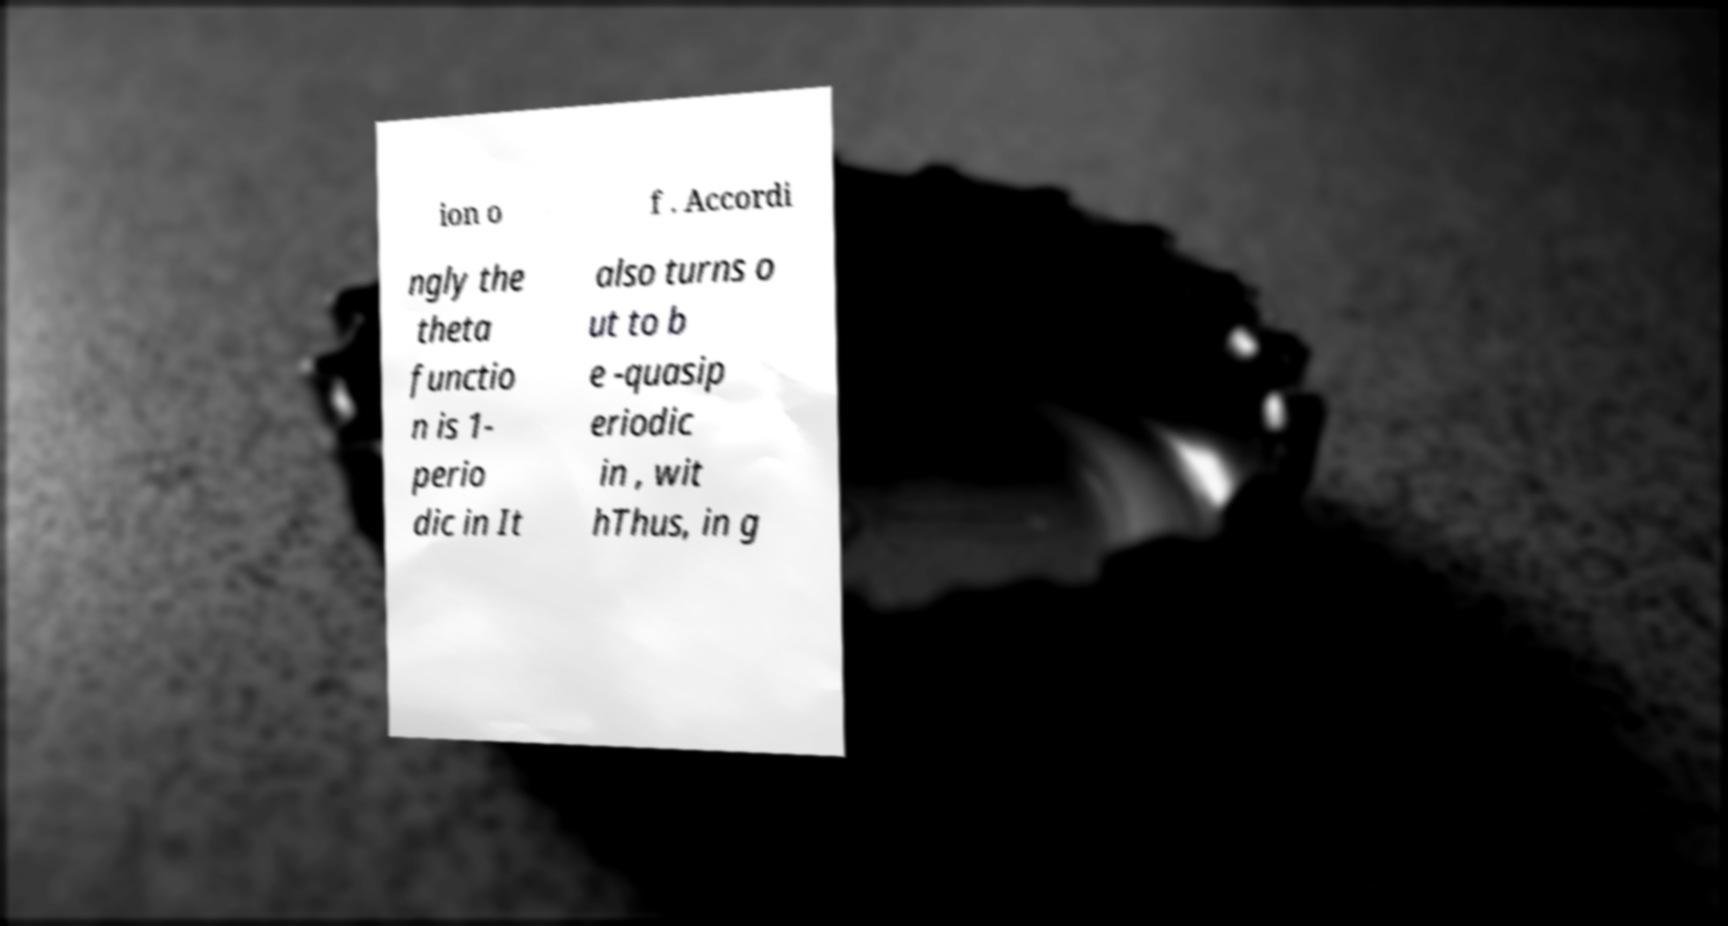For documentation purposes, I need the text within this image transcribed. Could you provide that? ion o f . Accordi ngly the theta functio n is 1- perio dic in It also turns o ut to b e -quasip eriodic in , wit hThus, in g 